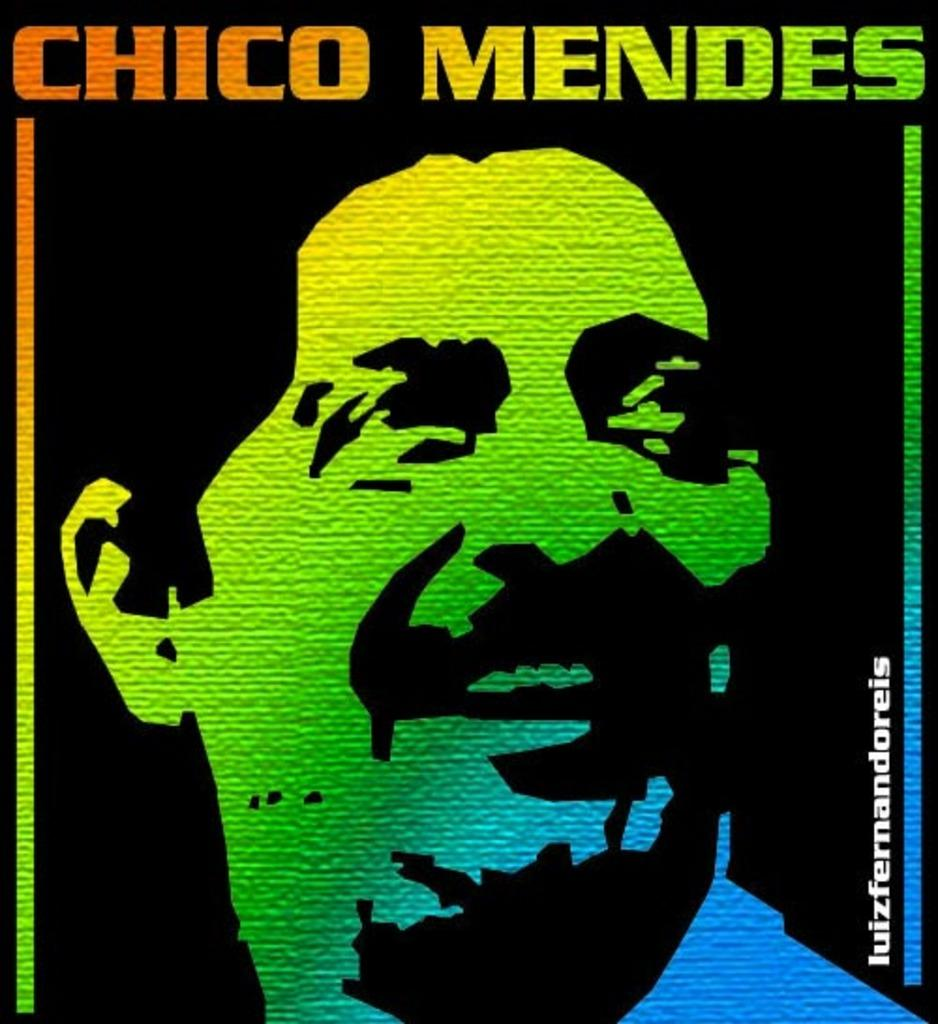Provide a one-sentence caption for the provided image. a poster of CHICO MENDEZ in colours. 